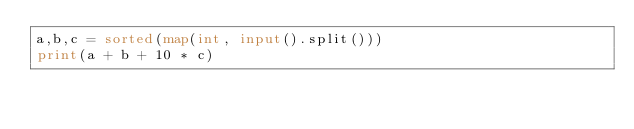<code> <loc_0><loc_0><loc_500><loc_500><_Python_>a,b,c = sorted(map(int, input().split()))
print(a + b + 10 * c)</code> 